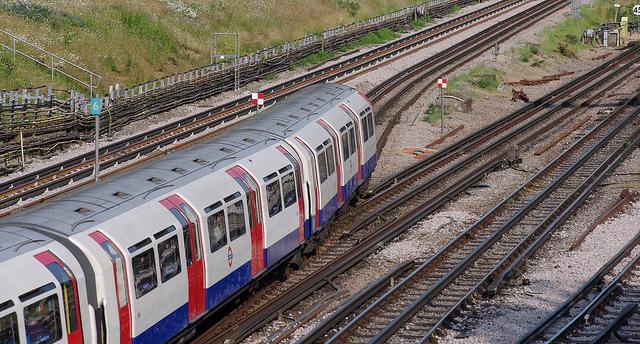Where is the train sitting?
Give a very brief answer. On tracks. Will the train collide with any other trains?
Short answer required. No. Is this a freight train?
Short answer required. No. 